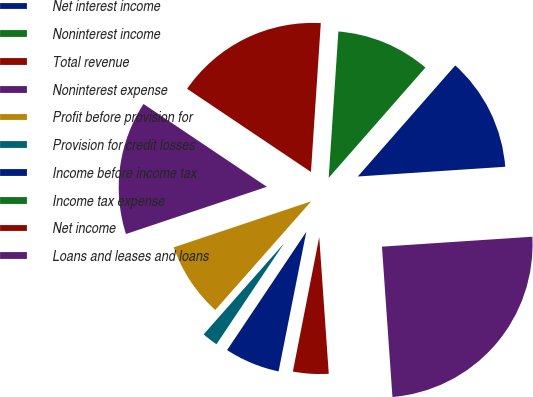Convert chart to OTSL. <chart><loc_0><loc_0><loc_500><loc_500><pie_chart><fcel>Net interest income<fcel>Noninterest income<fcel>Total revenue<fcel>Noninterest expense<fcel>Profit before provision for<fcel>Provision for credit losses<fcel>Income before income tax<fcel>Income tax expense<fcel>Net income<fcel>Loans and leases and loans<nl><fcel>12.49%<fcel>10.41%<fcel>16.64%<fcel>14.56%<fcel>8.34%<fcel>2.12%<fcel>6.27%<fcel>0.04%<fcel>4.19%<fcel>24.94%<nl></chart> 